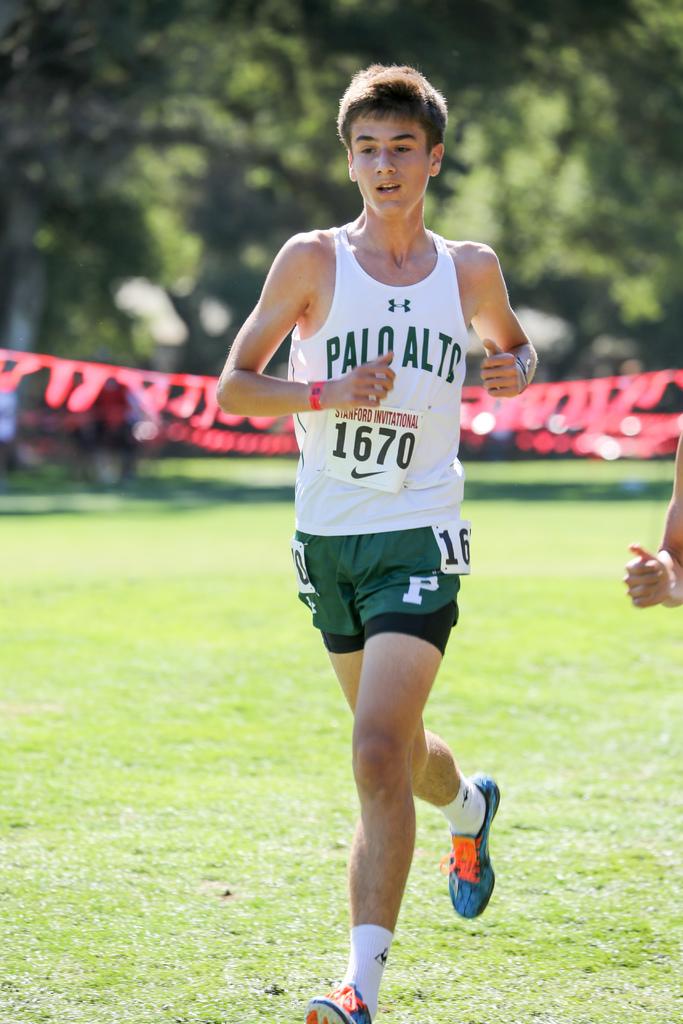What school is this runner competing for?
Give a very brief answer. Palo alto. What is the runner's number?
Your answer should be very brief. 1670. 